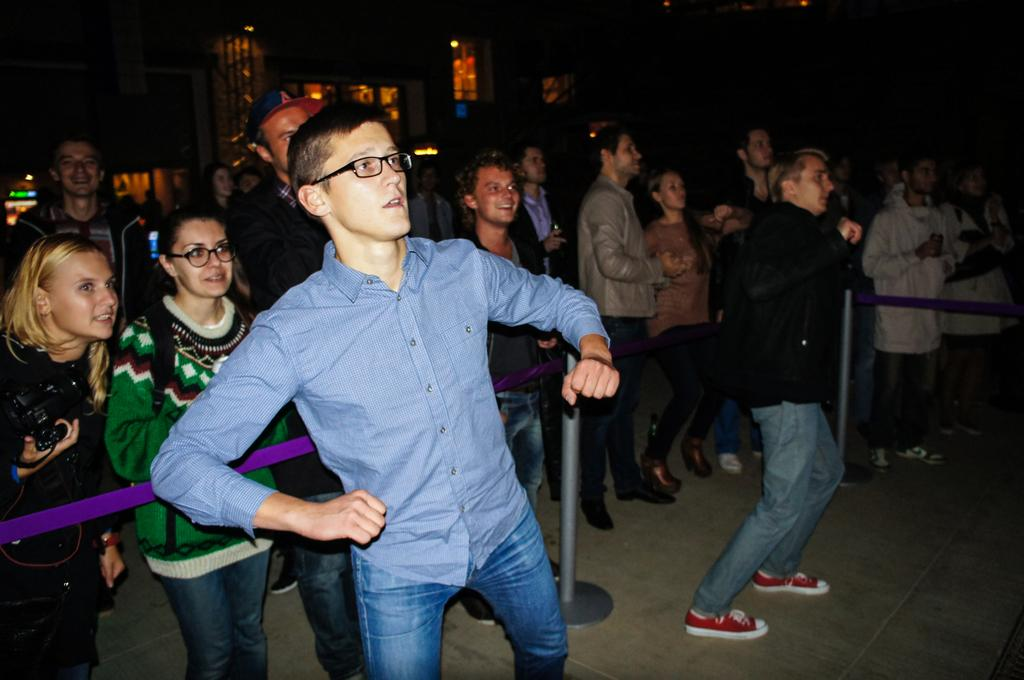How many people are in the image? There is a group of people in the image. What can be observed about the clothing of the people in the image? The people are wearing different color dresses. What can be seen on both sides of the image? There are ropes on both sides of the image. What type of structure is present in the image? There is a fence in the image. What can be seen illuminating the scene in the image? There are lights visible in the image. What color is the background of the image? The background of the image is black. What type of van is parked near the fence in the image? There is no van present in the image; only the group of people, ropes, fence, lights, and black background are visible. 